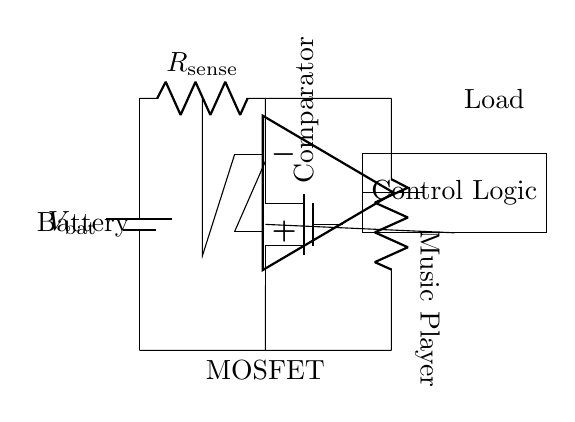what is the type of battery used in this circuit? The battery symbol in the circuit typically represents a standard battery type, indicated by the "V_bat" label, which denotes its voltage.
Answer: V_bat what component is used for current sensing? The circuit has a component labeled "R_sense," which is a resistor specifically used to sense the current flowing through it.
Answer: R_sense how many components are used for load in the circuit? The load in this circuit is represented by a single component, indicated as "Music Player," which suggests that it's the only load connected.
Answer: One what is the purpose of the MOSFET in this circuit? The MOSFET, labeled as "mosfet," serves as a switch to control the current flowing to the load, effectively providing protection by disconnecting it in case of a short circuit.
Answer: Switch what triggers the control logic in the circuit? The control logic is triggered by the output from the comparator, which monitors the voltage across the current sensing resistor to determine if a fault condition exists.
Answer: Comparator what is the role of the comparator in this circuit? The comparator compares the voltage across the sense resistor against a reference voltage to detect overcurrent conditions, thus aiding in activating the protection mechanism.
Answer: Overcurrent detection what is the connection between the load and the battery? The load is connected in series to the battery and the MOSFET, meaning all current flowing through the battery also flows through the load, which is essential for proper operation.
Answer: Series connection 